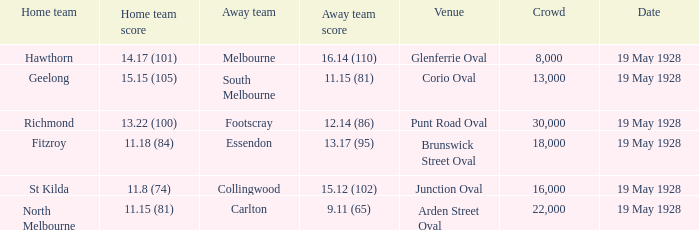What is the reported crowd size when essendon is playing as the visiting team? 1.0. 